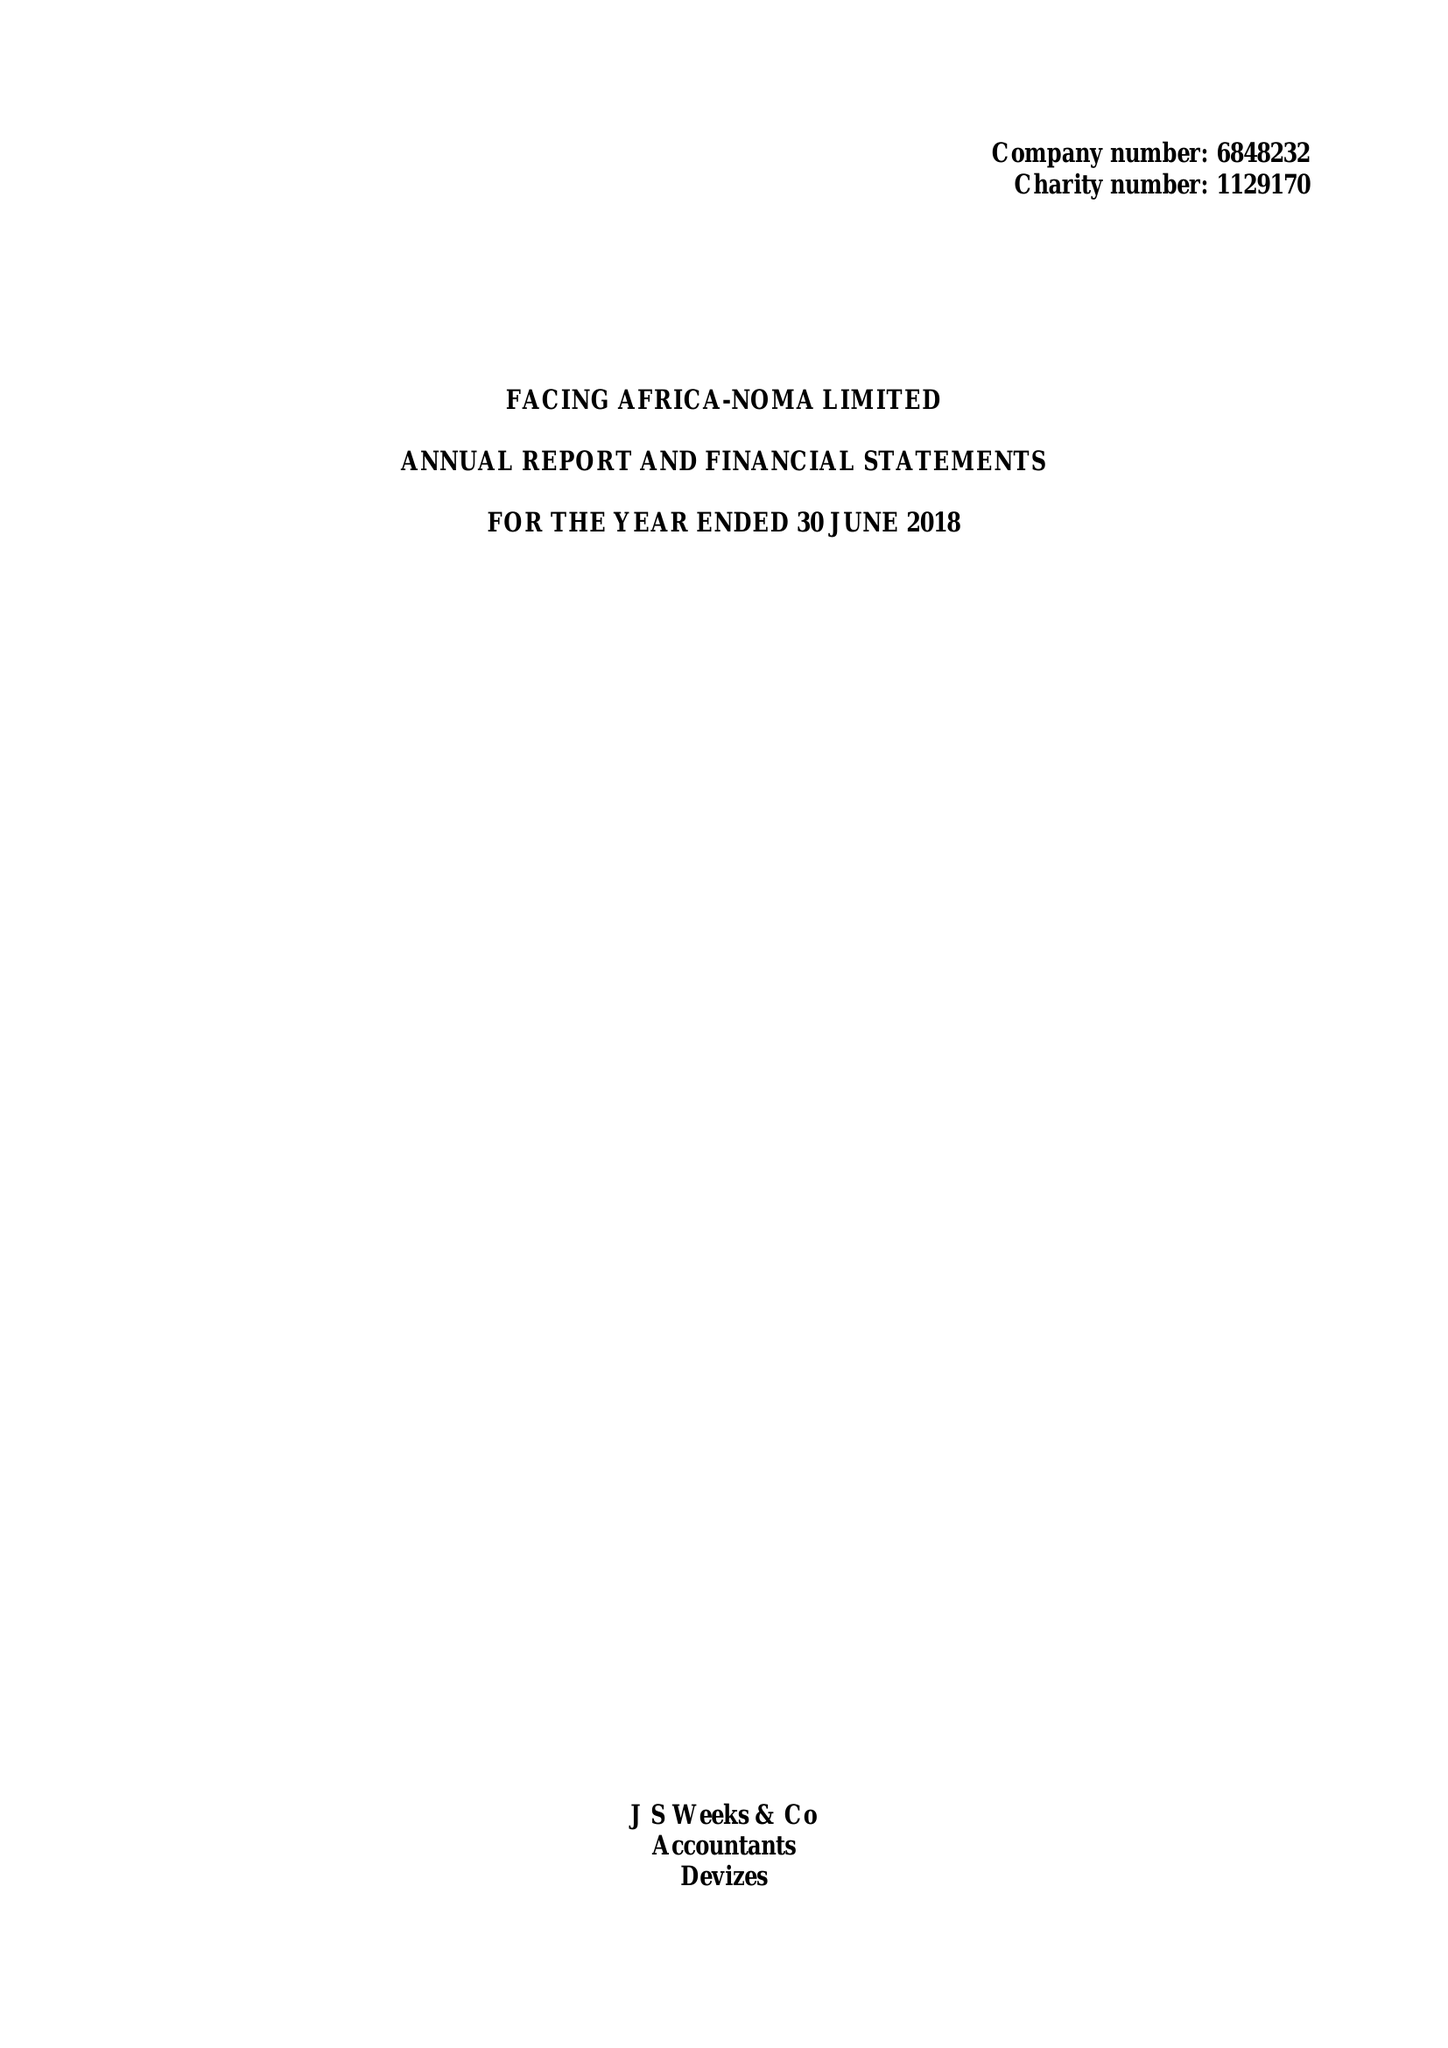What is the value for the address__street_line?
Answer the question using a single word or phrase. 1 WINE STREET 